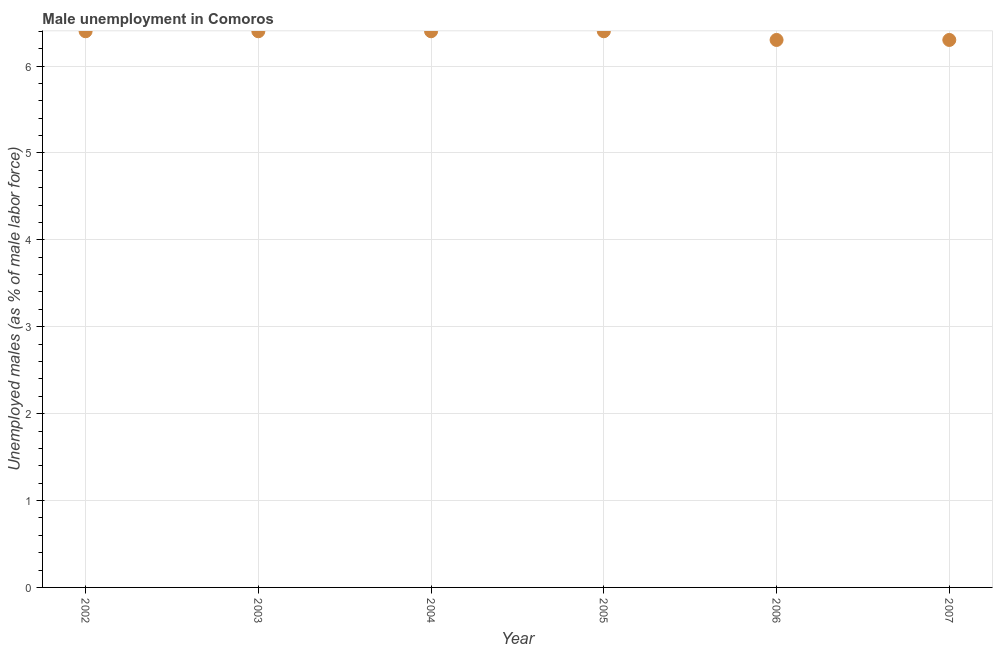What is the unemployed males population in 2002?
Provide a succinct answer. 6.4. Across all years, what is the maximum unemployed males population?
Keep it short and to the point. 6.4. Across all years, what is the minimum unemployed males population?
Ensure brevity in your answer.  6.3. In which year was the unemployed males population maximum?
Ensure brevity in your answer.  2002. In which year was the unemployed males population minimum?
Provide a short and direct response. 2006. What is the sum of the unemployed males population?
Give a very brief answer. 38.2. What is the difference between the unemployed males population in 2003 and 2007?
Offer a terse response. 0.1. What is the average unemployed males population per year?
Offer a terse response. 6.37. What is the median unemployed males population?
Provide a short and direct response. 6.4. Do a majority of the years between 2004 and 2006 (inclusive) have unemployed males population greater than 2 %?
Give a very brief answer. Yes. Is the unemployed males population in 2005 less than that in 2007?
Give a very brief answer. No. Is the difference between the unemployed males population in 2003 and 2004 greater than the difference between any two years?
Ensure brevity in your answer.  No. What is the difference between the highest and the lowest unemployed males population?
Keep it short and to the point. 0.1. How many years are there in the graph?
Your answer should be compact. 6. What is the title of the graph?
Give a very brief answer. Male unemployment in Comoros. What is the label or title of the X-axis?
Make the answer very short. Year. What is the label or title of the Y-axis?
Provide a short and direct response. Unemployed males (as % of male labor force). What is the Unemployed males (as % of male labor force) in 2002?
Give a very brief answer. 6.4. What is the Unemployed males (as % of male labor force) in 2003?
Offer a terse response. 6.4. What is the Unemployed males (as % of male labor force) in 2004?
Provide a succinct answer. 6.4. What is the Unemployed males (as % of male labor force) in 2005?
Offer a very short reply. 6.4. What is the Unemployed males (as % of male labor force) in 2006?
Ensure brevity in your answer.  6.3. What is the Unemployed males (as % of male labor force) in 2007?
Offer a very short reply. 6.3. What is the difference between the Unemployed males (as % of male labor force) in 2002 and 2004?
Your response must be concise. 0. What is the difference between the Unemployed males (as % of male labor force) in 2004 and 2006?
Keep it short and to the point. 0.1. What is the difference between the Unemployed males (as % of male labor force) in 2004 and 2007?
Your answer should be compact. 0.1. What is the difference between the Unemployed males (as % of male labor force) in 2005 and 2007?
Provide a succinct answer. 0.1. What is the ratio of the Unemployed males (as % of male labor force) in 2002 to that in 2003?
Your response must be concise. 1. What is the ratio of the Unemployed males (as % of male labor force) in 2002 to that in 2004?
Offer a very short reply. 1. What is the ratio of the Unemployed males (as % of male labor force) in 2003 to that in 2005?
Your response must be concise. 1. What is the ratio of the Unemployed males (as % of male labor force) in 2003 to that in 2007?
Keep it short and to the point. 1.02. What is the ratio of the Unemployed males (as % of male labor force) in 2004 to that in 2006?
Offer a very short reply. 1.02. What is the ratio of the Unemployed males (as % of male labor force) in 2004 to that in 2007?
Ensure brevity in your answer.  1.02. What is the ratio of the Unemployed males (as % of male labor force) in 2005 to that in 2006?
Provide a short and direct response. 1.02. What is the ratio of the Unemployed males (as % of male labor force) in 2005 to that in 2007?
Your response must be concise. 1.02. What is the ratio of the Unemployed males (as % of male labor force) in 2006 to that in 2007?
Give a very brief answer. 1. 